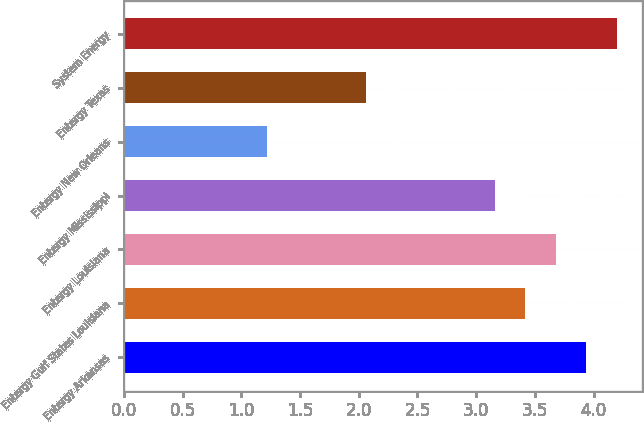Convert chart. <chart><loc_0><loc_0><loc_500><loc_500><bar_chart><fcel>Entergy Arkansas<fcel>Entergy Gulf States Louisiana<fcel>Entergy Louisiana<fcel>Entergy Mississippi<fcel>Entergy New Orleans<fcel>Entergy Texas<fcel>System Energy<nl><fcel>3.94<fcel>3.42<fcel>3.68<fcel>3.16<fcel>1.22<fcel>2.06<fcel>4.2<nl></chart> 